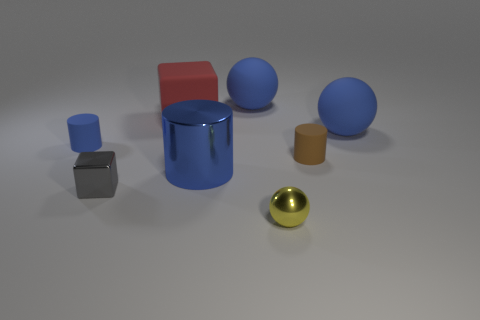Is there a small rubber object that has the same color as the large cylinder?
Your answer should be compact. Yes. There is another metallic thing that is the same size as the gray thing; what color is it?
Provide a succinct answer. Yellow. Does the shiny cylinder have the same color as the small matte object on the left side of the big blue metal object?
Your answer should be compact. Yes. There is another tiny thing that is the same shape as the small blue matte thing; what is its color?
Provide a succinct answer. Brown. Are there fewer big metal things that are to the right of the small sphere than objects behind the brown cylinder?
Offer a very short reply. Yes. How many other things are the same shape as the tiny gray thing?
Offer a terse response. 1. There is a big matte object right of the tiny brown matte object; is it the same color as the large shiny object?
Provide a short and direct response. Yes. There is a tiny object that is behind the small gray shiny cube and on the right side of the red rubber object; what is its shape?
Offer a very short reply. Cylinder. There is a rubber ball on the right side of the brown cylinder; what color is it?
Provide a short and direct response. Blue. Is there any other thing of the same color as the tiny ball?
Your answer should be very brief. No. 